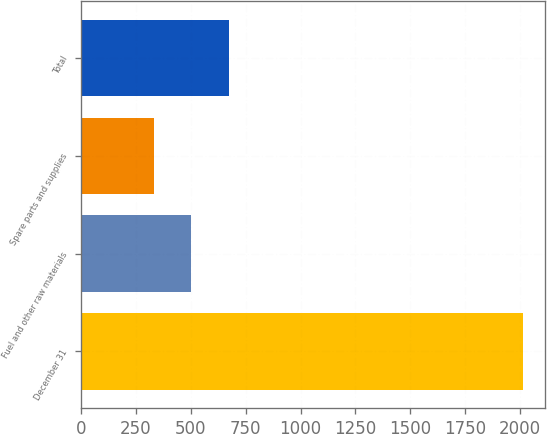<chart> <loc_0><loc_0><loc_500><loc_500><bar_chart><fcel>December 31<fcel>Fuel and other raw materials<fcel>Spare parts and supplies<fcel>Total<nl><fcel>2015<fcel>500.3<fcel>332<fcel>675<nl></chart> 